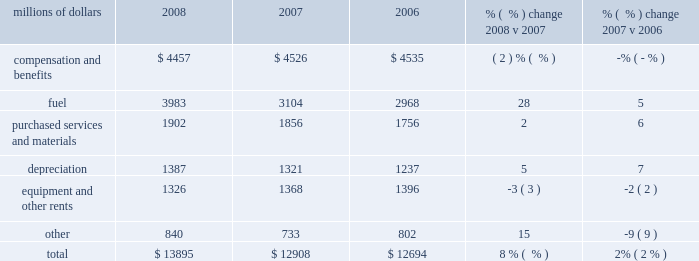Volume declines in cement , some agricultural products , and newsprint shipments partially offset the increases .
Operating expenses millions of dollars 2008 2007 2006 % (  % ) change 2008 v 2007 % (  % ) change 2007 v 2006 .
Operating expenses increased $ 987 million in 2008 .
Our fuel price per gallon rose 39% ( 39 % ) during the year , increasing operating expenses by $ 1.1 billion compared to 2007 .
Wage , benefit , and materials inflation , higher depreciation , and costs associated with the january cascade mudslide and hurricanes gustav and ike also increased expenses during the year .
Cost savings from productivity improvements , better resource utilization , and lower volume helped offset these increases .
Operating expenses increased $ 214 million in 2007 versus 2006 .
Higher fuel prices , which rose 9% ( 9 % ) during the period , increased operating expenses by $ 242 million .
Wage , benefit and materials inflation and higher depreciation expense also increased expenses during the year .
Productivity improvements , better resource utilization , and a lower fuel consumption rate helped offset these increases .
Compensation and benefits 2013 compensation and benefits include wages , payroll taxes , health and welfare costs , pension costs , other postretirement benefits , and incentive costs .
Productivity initiatives in all areas , combined with lower volume , led to a 4% ( 4 % ) decline in our workforce for 2008 , saving $ 227 million compared to 2007 .
Conversely , general wage and benefit inflation and higher pension and postretirement benefits increased expenses in 2008 , partially offsetting these reductions .
Operational improvements and lower volume levels in 2007 led to a 1% ( 1 % ) decline in our workforce , saving $ 79 million in 2007 compared to 2006 .
A smaller workforce and less need for new train personnel reduced training costs during the year , which contributed to the improvement .
General wage and benefit inflation mostly offset the reductions , reflecting higher salaries and wages and the impact of higher healthcare and other benefit costs .
Fuel 2013 fuel includes locomotive fuel and gasoline for highway and non-highway vehicles and heavy equipment .
Diesel fuel prices , which averaged $ 3.15 per gallon ( including taxes and transportation costs ) in 2008 compared to $ 2.27 per gallon in 2007 , increased expenses by $ 1.1 billion .
A 4% ( 4 % ) improvement in our fuel consumption rate resulted in $ 136 million of cost savings due to the use of newer , more fuel 2008 operating expenses .
What percent of total operating expenses was fuel in 2007? 
Computations: (3104 / 12908)
Answer: 0.24047. 